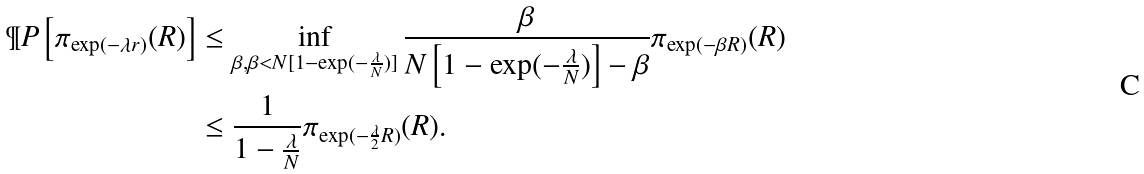Convert formula to latex. <formula><loc_0><loc_0><loc_500><loc_500>\P P \left [ \pi _ { \exp ( - \lambda r ) } ( R ) \right ] & \leq \inf _ { \beta , \beta < N [ 1 - \exp ( - \frac { \lambda } { N } ) ] } \frac { \beta } { N \left [ 1 - \exp ( - \frac { \lambda } { N } ) \right ] - \beta } \pi _ { \exp ( - \beta R ) } ( R ) \\ & \leq \frac { 1 } { 1 - \frac { \lambda } { N } } \pi _ { \exp ( - \frac { \lambda } { 2 } R ) } ( R ) .</formula> 